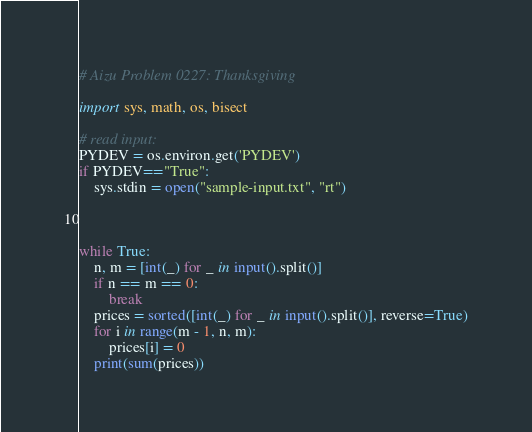Convert code to text. <code><loc_0><loc_0><loc_500><loc_500><_Python_># Aizu Problem 0227: Thanksgiving

import sys, math, os, bisect

# read input:
PYDEV = os.environ.get('PYDEV')
if PYDEV=="True":
    sys.stdin = open("sample-input.txt", "rt")



while True:
    n, m = [int(_) for _ in input().split()]
    if n == m == 0:
        break
    prices = sorted([int(_) for _ in input().split()], reverse=True)
    for i in range(m - 1, n, m):
        prices[i] = 0
    print(sum(prices))</code> 